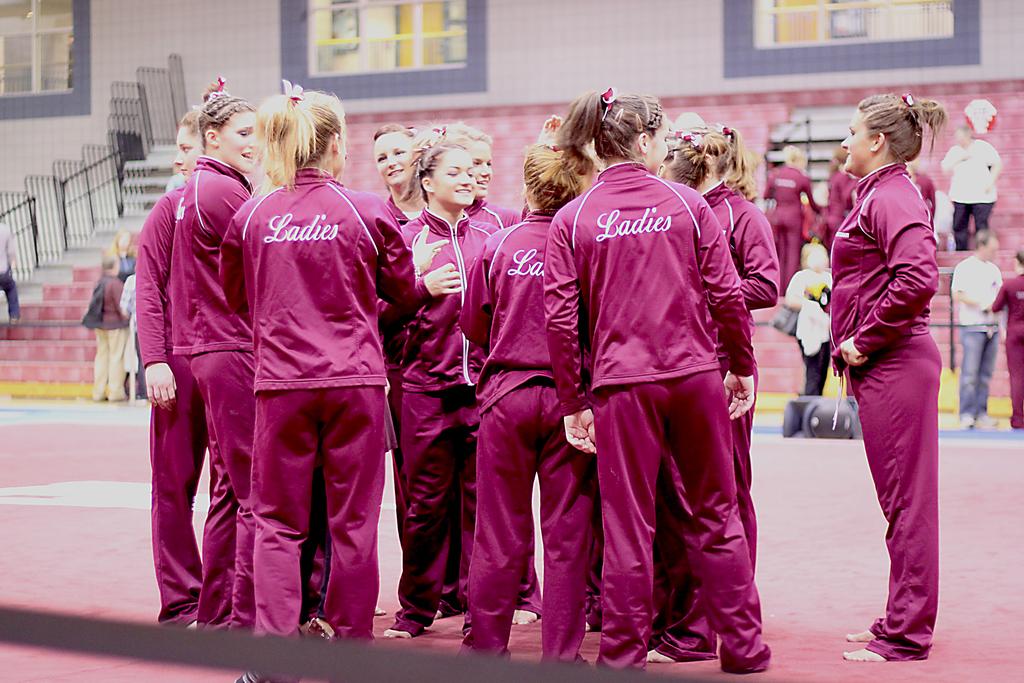What are the people dressed in pink?
Provide a succinct answer. Ladies. 